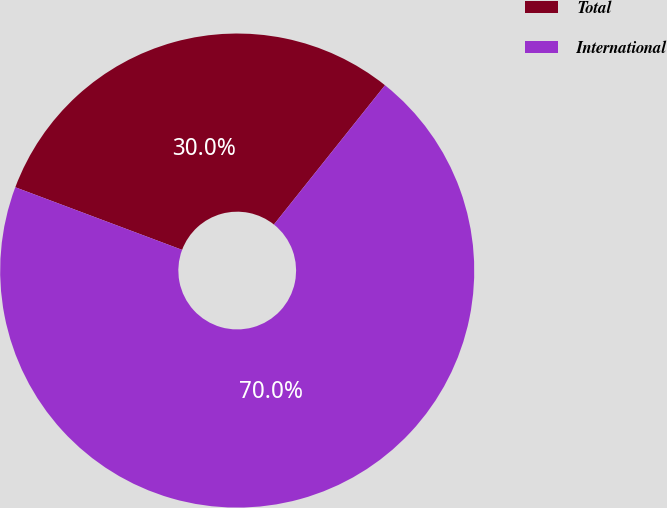Convert chart to OTSL. <chart><loc_0><loc_0><loc_500><loc_500><pie_chart><fcel>Total<fcel>International<nl><fcel>30.0%<fcel>70.0%<nl></chart> 